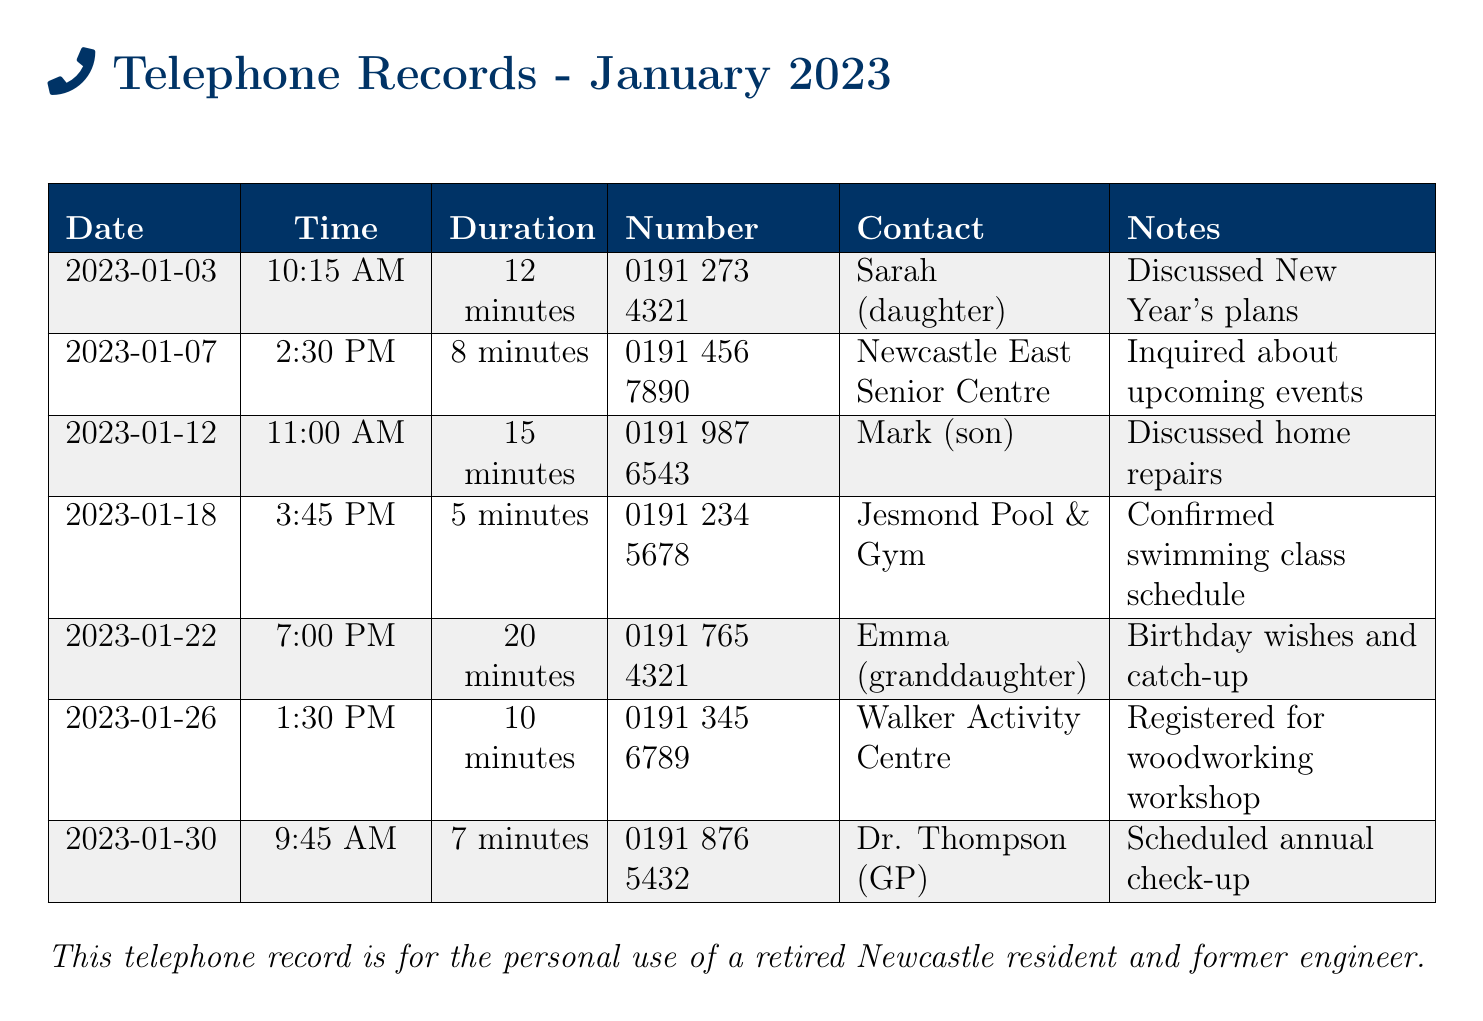What is the date of the call to Sarah? The date of the call to Sarah is listed as the specific date in the call log.
Answer: 2023-01-03 How long was the call with Newcastle East Senior Centre? The duration of the call is specified in the document under the relevant contact entry.
Answer: 8 minutes Who did the caller speak to on January 22? The contact name for the call on January 22 is provided in the document's notes.
Answer: Emma (granddaughter) What was discussed during the call with Mark? The notes section contains details on the topics discussed during the call with Mark.
Answer: Discussed home repairs How many calls were made to family members? The total number of calls made to family members can be counted from the document entries.
Answer: 3 Which center was contacted to register for a workshop? The specific center contacted can be determined from the relevant entry in the call log.
Answer: Walker Activity Centre What time was the call to Dr. Thompson? The time of the call is recorded in the document under the relevant contact.
Answer: 9:45 AM Which day did the longest call occur? The longest call duration can be identified by comparing the duration of each call in the log.
Answer: January 22 